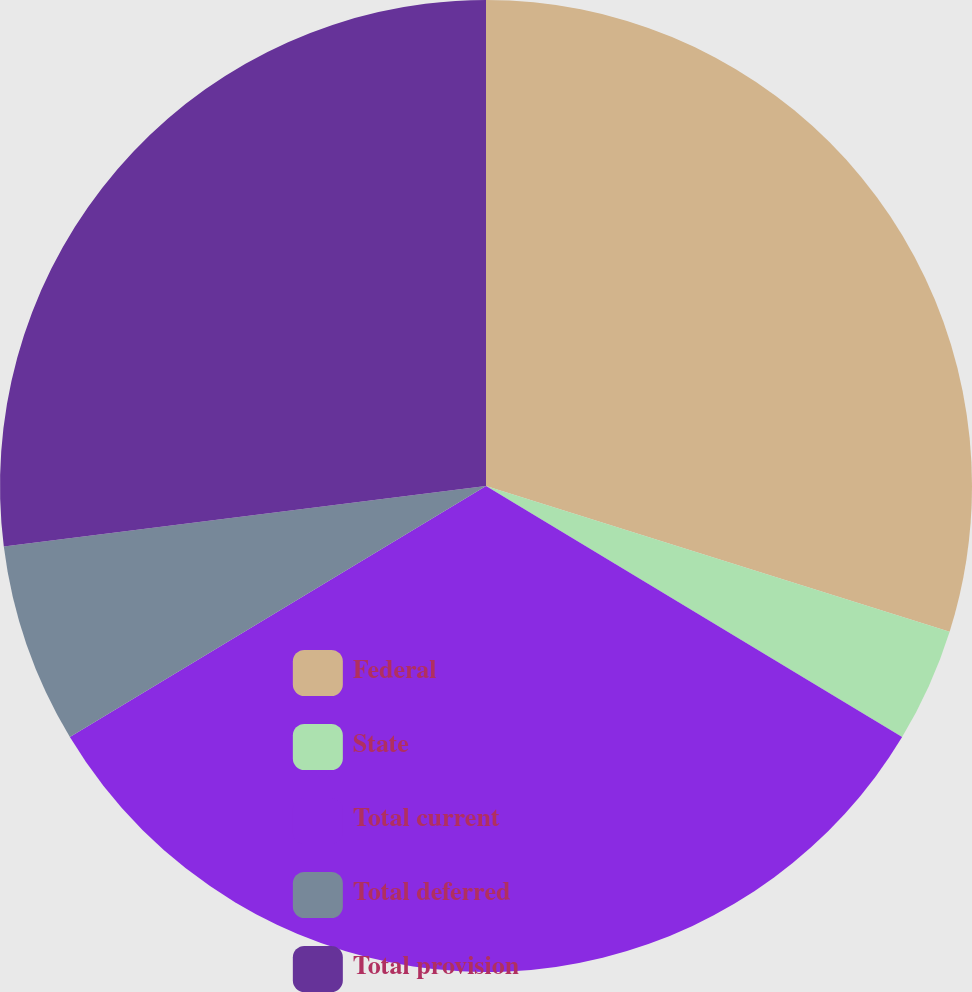<chart> <loc_0><loc_0><loc_500><loc_500><pie_chart><fcel>Federal<fcel>State<fcel>Total current<fcel>Total deferred<fcel>Total provision<nl><fcel>29.85%<fcel>3.79%<fcel>32.72%<fcel>6.65%<fcel>26.99%<nl></chart> 